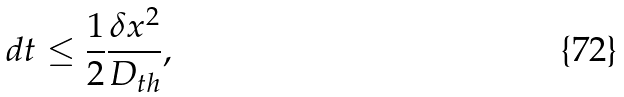Convert formula to latex. <formula><loc_0><loc_0><loc_500><loc_500>d t \leq \frac { 1 } { 2 } \frac { \delta x ^ { 2 } } { D _ { t h } } ,</formula> 